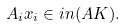<formula> <loc_0><loc_0><loc_500><loc_500>A _ { i } x _ { i } \in \L i n ( A K ) .</formula> 